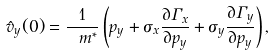Convert formula to latex. <formula><loc_0><loc_0><loc_500><loc_500>\hat { v } _ { y } ( 0 ) = \frac { 1 } { \ m ^ { * } } \left ( p _ { y } + \sigma _ { x } \frac { \partial \Gamma _ { x } } { \partial p _ { y } } + \sigma _ { y } \frac { \partial \Gamma _ { y } } { \partial p _ { y } } \right ) ,</formula> 